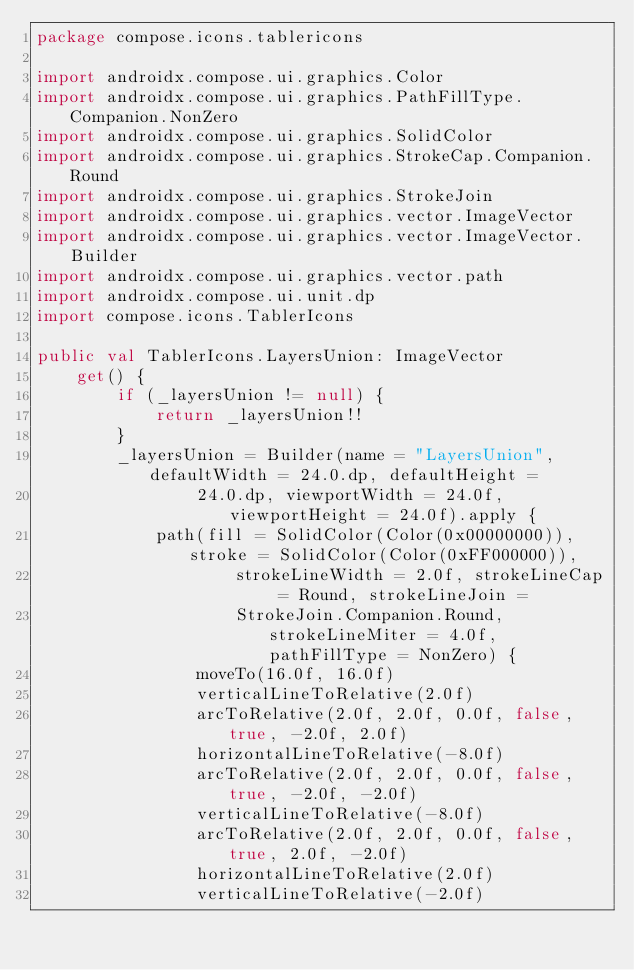<code> <loc_0><loc_0><loc_500><loc_500><_Kotlin_>package compose.icons.tablericons

import androidx.compose.ui.graphics.Color
import androidx.compose.ui.graphics.PathFillType.Companion.NonZero
import androidx.compose.ui.graphics.SolidColor
import androidx.compose.ui.graphics.StrokeCap.Companion.Round
import androidx.compose.ui.graphics.StrokeJoin
import androidx.compose.ui.graphics.vector.ImageVector
import androidx.compose.ui.graphics.vector.ImageVector.Builder
import androidx.compose.ui.graphics.vector.path
import androidx.compose.ui.unit.dp
import compose.icons.TablerIcons

public val TablerIcons.LayersUnion: ImageVector
    get() {
        if (_layersUnion != null) {
            return _layersUnion!!
        }
        _layersUnion = Builder(name = "LayersUnion", defaultWidth = 24.0.dp, defaultHeight =
                24.0.dp, viewportWidth = 24.0f, viewportHeight = 24.0f).apply {
            path(fill = SolidColor(Color(0x00000000)), stroke = SolidColor(Color(0xFF000000)),
                    strokeLineWidth = 2.0f, strokeLineCap = Round, strokeLineJoin =
                    StrokeJoin.Companion.Round, strokeLineMiter = 4.0f, pathFillType = NonZero) {
                moveTo(16.0f, 16.0f)
                verticalLineToRelative(2.0f)
                arcToRelative(2.0f, 2.0f, 0.0f, false, true, -2.0f, 2.0f)
                horizontalLineToRelative(-8.0f)
                arcToRelative(2.0f, 2.0f, 0.0f, false, true, -2.0f, -2.0f)
                verticalLineToRelative(-8.0f)
                arcToRelative(2.0f, 2.0f, 0.0f, false, true, 2.0f, -2.0f)
                horizontalLineToRelative(2.0f)
                verticalLineToRelative(-2.0f)</code> 